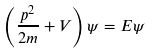<formula> <loc_0><loc_0><loc_500><loc_500>\left ( { \frac { p ^ { 2 } } { 2 m } } + V \right ) \psi = E \psi</formula> 